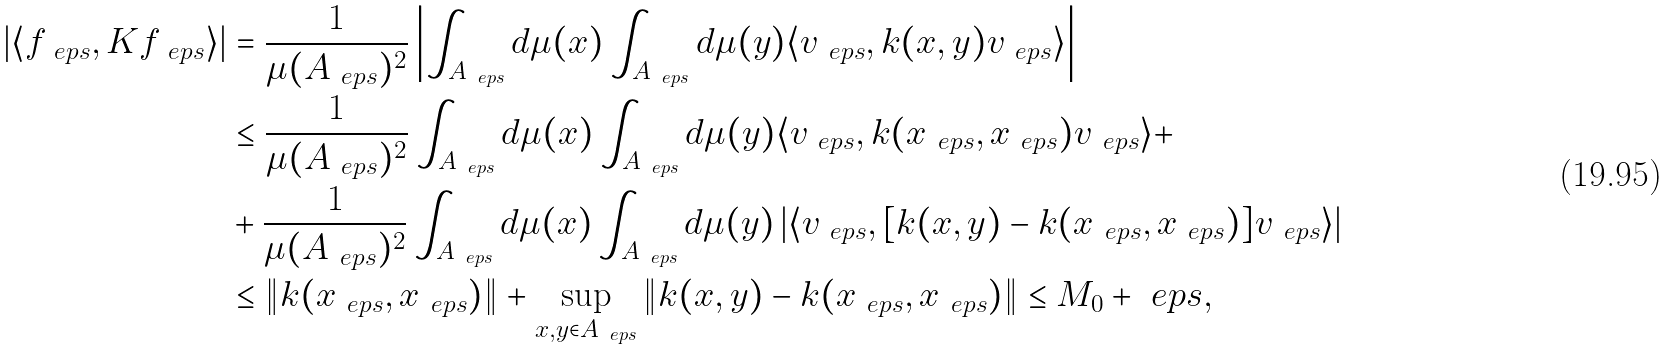Convert formula to latex. <formula><loc_0><loc_0><loc_500><loc_500>| \langle f _ { \ e p s } , K f _ { \ e p s } \rangle | & = \frac { 1 } { \mu ( A _ { \ e p s } ) ^ { 2 } } \left | \int _ { A _ { \ e p s } } d \mu ( x ) \int _ { A _ { \ e p s } } d \mu ( y ) \langle v _ { \ e p s } , k ( x , y ) v _ { \ e p s } \rangle \right | \\ & \leq \frac { 1 } { \mu ( A _ { \ e p s } ) ^ { 2 } } \int _ { A _ { \ e p s } } d \mu ( x ) \int _ { A _ { \ e p s } } d \mu ( y ) \langle v _ { \ e p s } , k ( x _ { \ e p s } , x _ { \ e p s } ) v _ { \ e p s } \rangle + \\ & + \frac { 1 } { \mu ( A _ { \ e p s } ) ^ { 2 } } \int _ { A _ { \ e p s } } d \mu ( x ) \int _ { A _ { \ e p s } } d \mu ( y ) \left | \langle v _ { \ e p s } , [ k ( x , y ) - k ( x _ { \ e p s } , x _ { \ e p s } ) ] v _ { \ e p s } \rangle \right | \\ & \leq \| k ( x _ { \ e p s } , x _ { \ e p s } ) \| + \sup _ { x , y \in A _ { \ e p s } } \| k ( x , y ) - k ( x _ { \ e p s } , x _ { \ e p s } ) \| \leq M _ { 0 } + \ e p s ,</formula> 